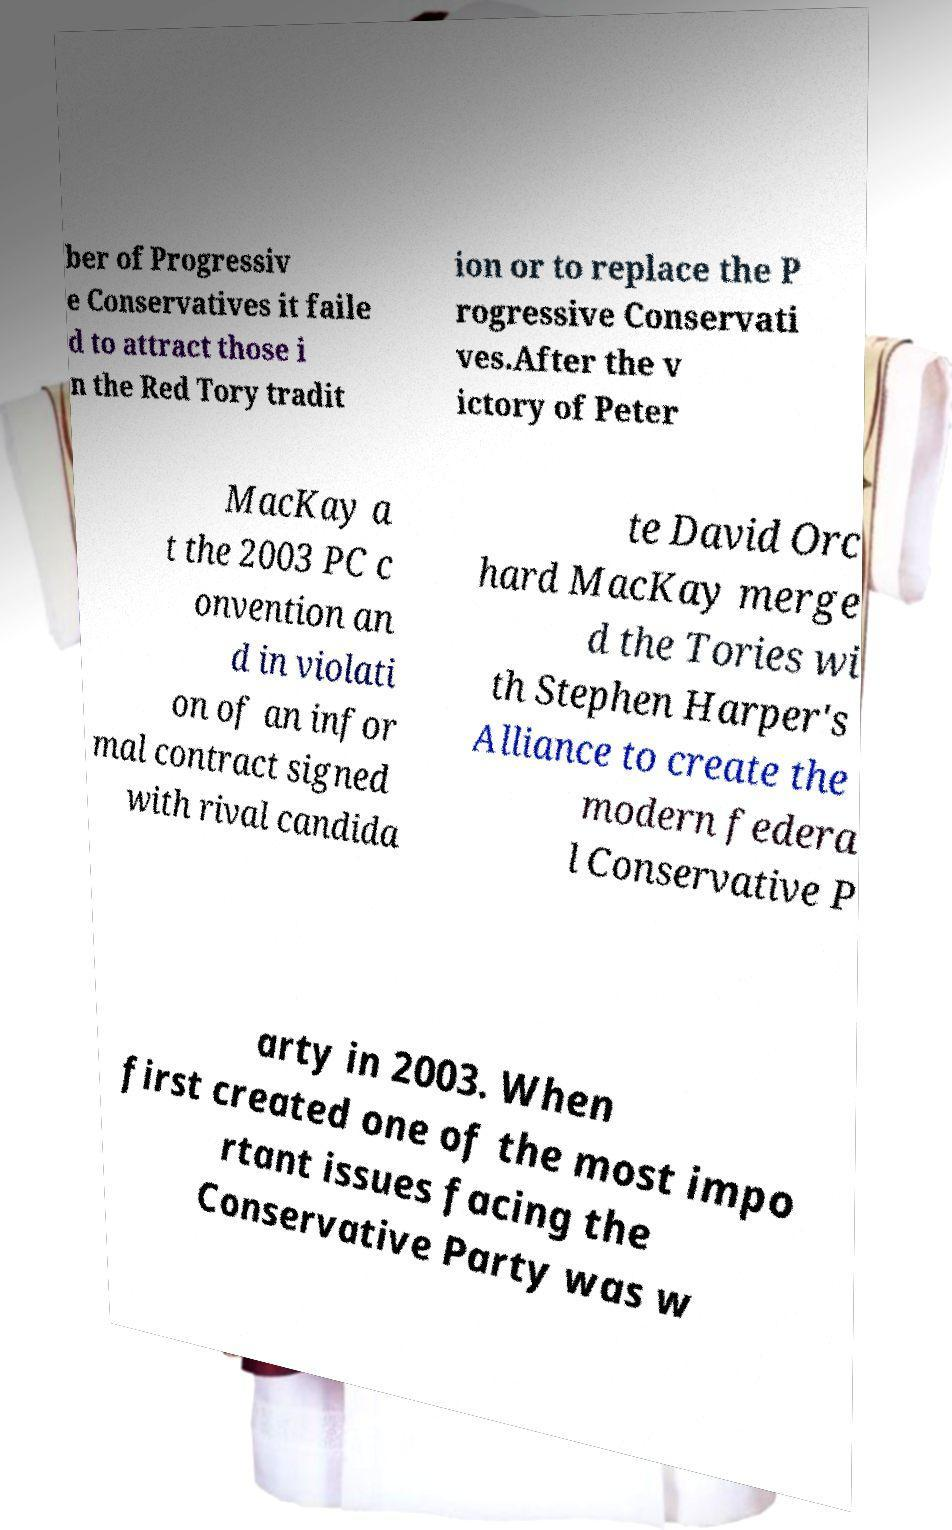What messages or text are displayed in this image? I need them in a readable, typed format. ber of Progressiv e Conservatives it faile d to attract those i n the Red Tory tradit ion or to replace the P rogressive Conservati ves.After the v ictory of Peter MacKay a t the 2003 PC c onvention an d in violati on of an infor mal contract signed with rival candida te David Orc hard MacKay merge d the Tories wi th Stephen Harper's Alliance to create the modern federa l Conservative P arty in 2003. When first created one of the most impo rtant issues facing the Conservative Party was w 